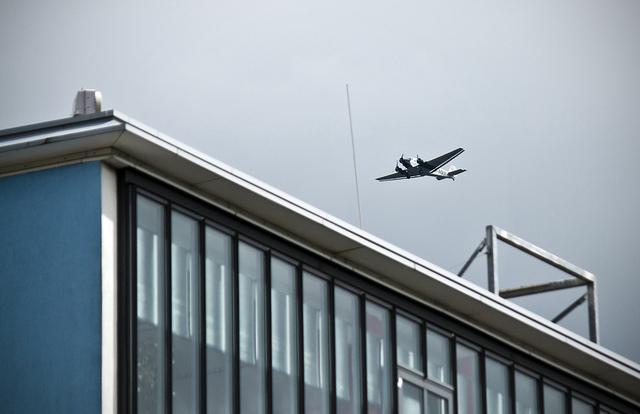How many people are surf boards are in this picture?
Give a very brief answer. 0. 